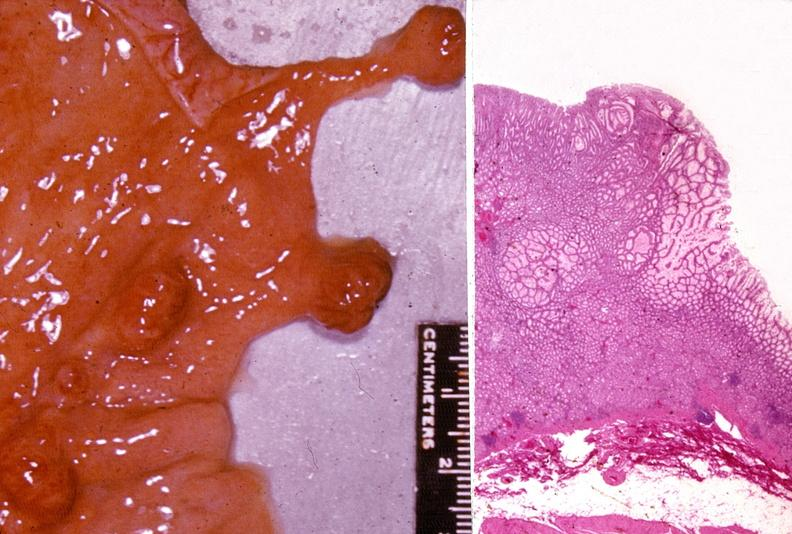s aldehyde fuscin present?
Answer the question using a single word or phrase. No 